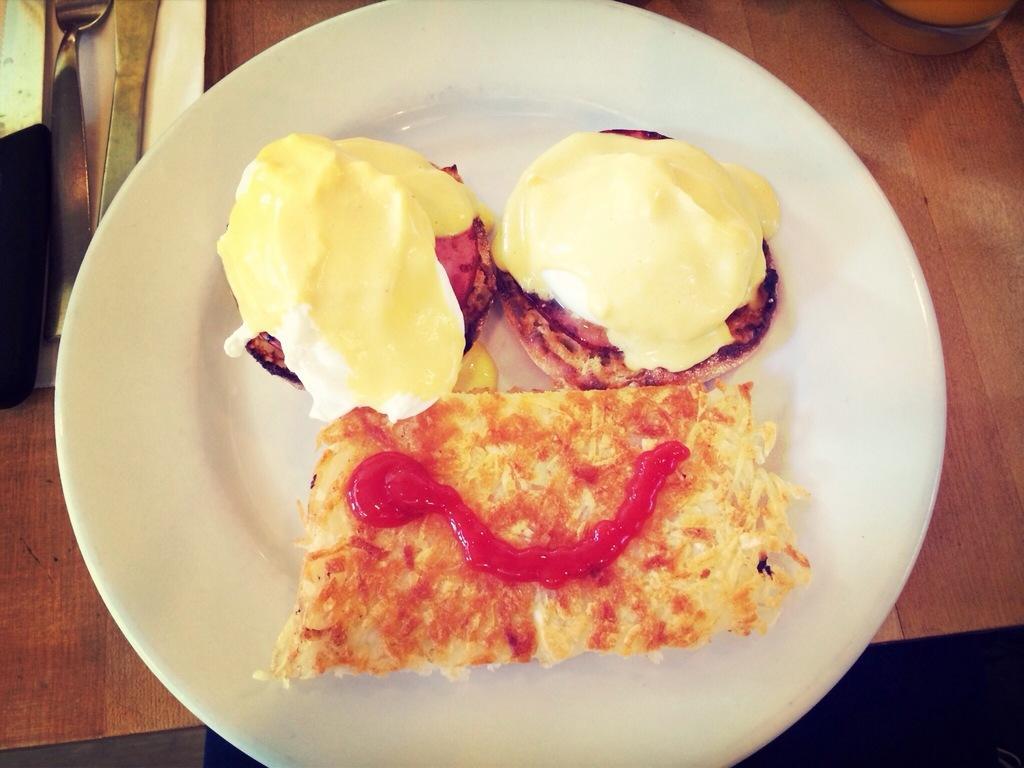How would you summarize this image in a sentence or two? In this picture I can see a white plate on which there is food which is of cream, red and brown in color and this white plate is on a brown color surface and I see few things on the top right. 